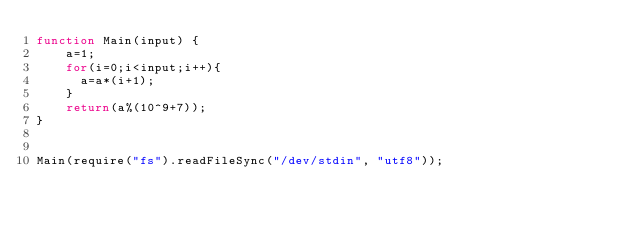<code> <loc_0><loc_0><loc_500><loc_500><_JavaScript_>function Main(input) {
    a=1;
    for(i=0;i<input;i++){
      a=a*(i+1);
    }
    return(a%(10^9+7));
}


Main(require("fs").readFileSync("/dev/stdin", "utf8"));</code> 